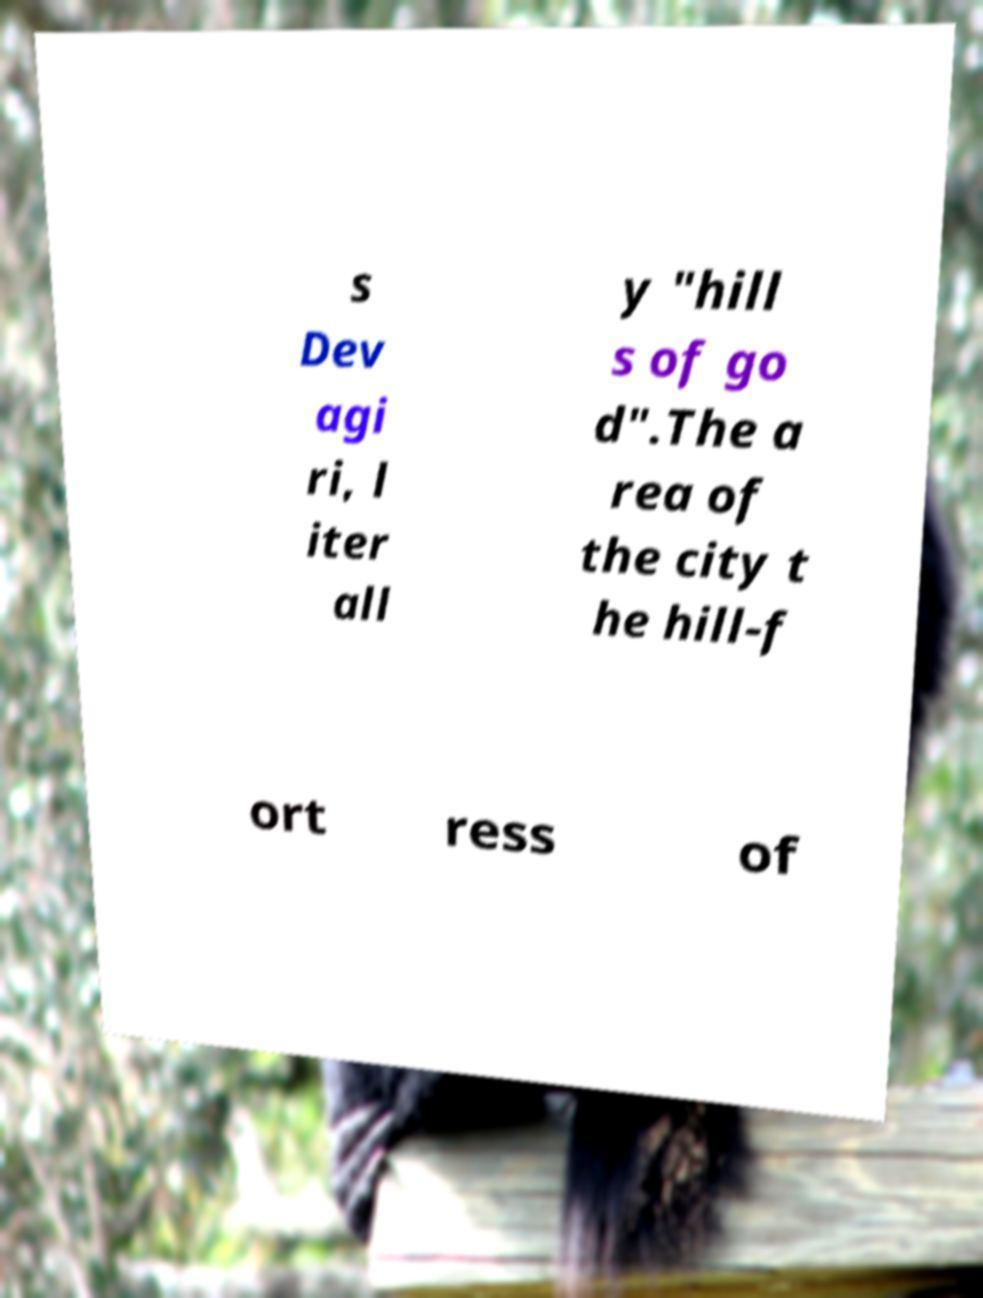Can you read and provide the text displayed in the image?This photo seems to have some interesting text. Can you extract and type it out for me? s Dev agi ri, l iter all y "hill s of go d".The a rea of the city t he hill-f ort ress of 